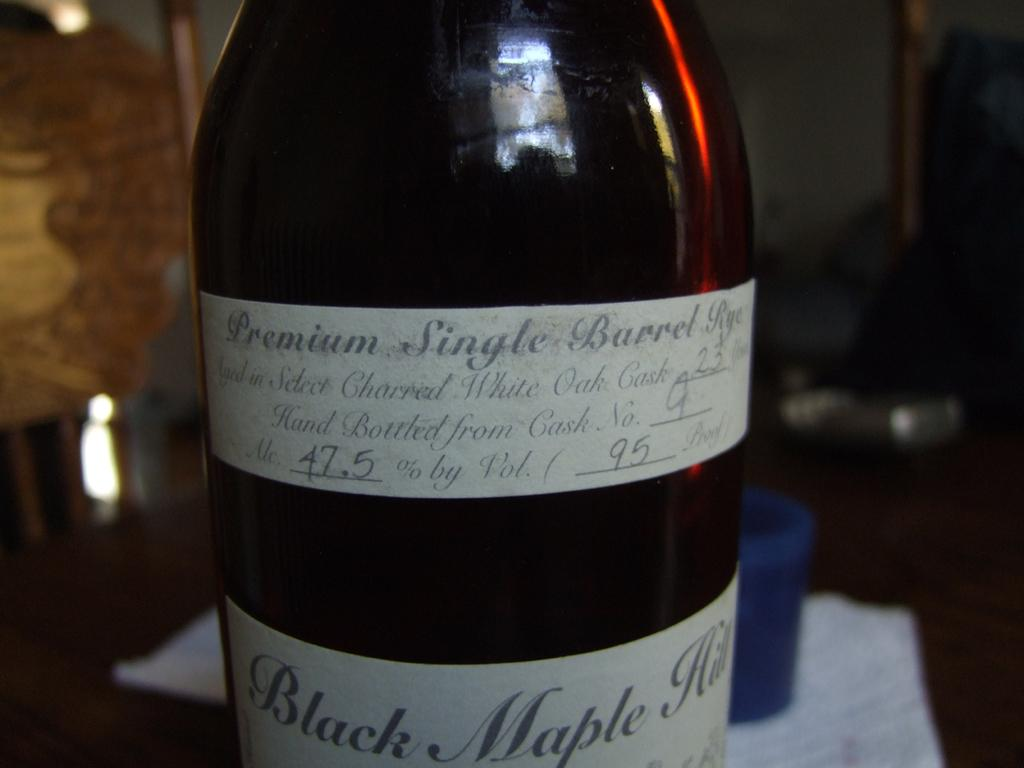What is the main object in the center of the image? There is a wine bottle in the center of the image. What can be seen on the wine bottle? There is writing on the wine bottle. What can be seen in the background of the image? There is a wall, a table, and a mug in the background of the image. Are there any other objects visible in the background? Yes, there are other objects visible in the background of the image. What type of cactus is growing in the wine bottle in the image? There is no cactus growing in the wine bottle in the image; it contains wine. What color is the gold object on the table in the image? There is no gold object present on the table in the image. 